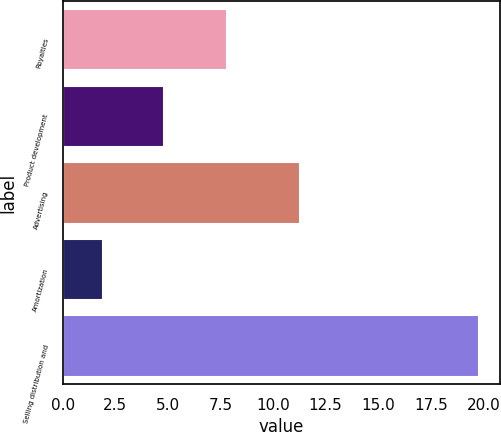Convert chart. <chart><loc_0><loc_0><loc_500><loc_500><bar_chart><fcel>Royalties<fcel>Product development<fcel>Advertising<fcel>Amortization<fcel>Selling distribution and<nl><fcel>7.8<fcel>4.8<fcel>11.3<fcel>1.9<fcel>19.8<nl></chart> 